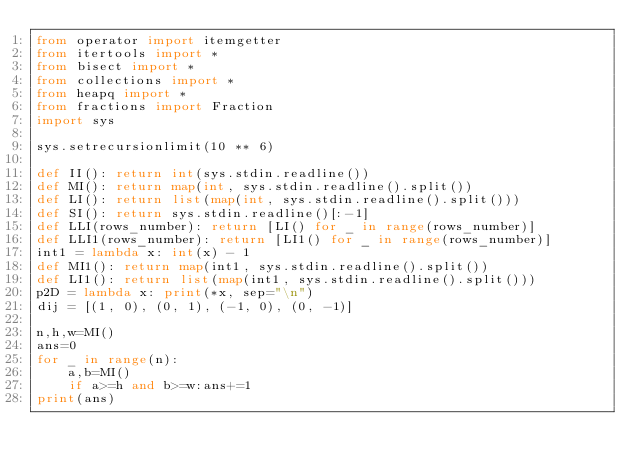<code> <loc_0><loc_0><loc_500><loc_500><_Python_>from operator import itemgetter
from itertools import *
from bisect import *
from collections import *
from heapq import *
from fractions import Fraction
import sys

sys.setrecursionlimit(10 ** 6)

def II(): return int(sys.stdin.readline())
def MI(): return map(int, sys.stdin.readline().split())
def LI(): return list(map(int, sys.stdin.readline().split()))
def SI(): return sys.stdin.readline()[:-1]
def LLI(rows_number): return [LI() for _ in range(rows_number)]
def LLI1(rows_number): return [LI1() for _ in range(rows_number)]
int1 = lambda x: int(x) - 1
def MI1(): return map(int1, sys.stdin.readline().split())
def LI1(): return list(map(int1, sys.stdin.readline().split()))
p2D = lambda x: print(*x, sep="\n")
dij = [(1, 0), (0, 1), (-1, 0), (0, -1)]

n,h,w=MI()
ans=0
for _ in range(n):
    a,b=MI()
    if a>=h and b>=w:ans+=1
print(ans)</code> 